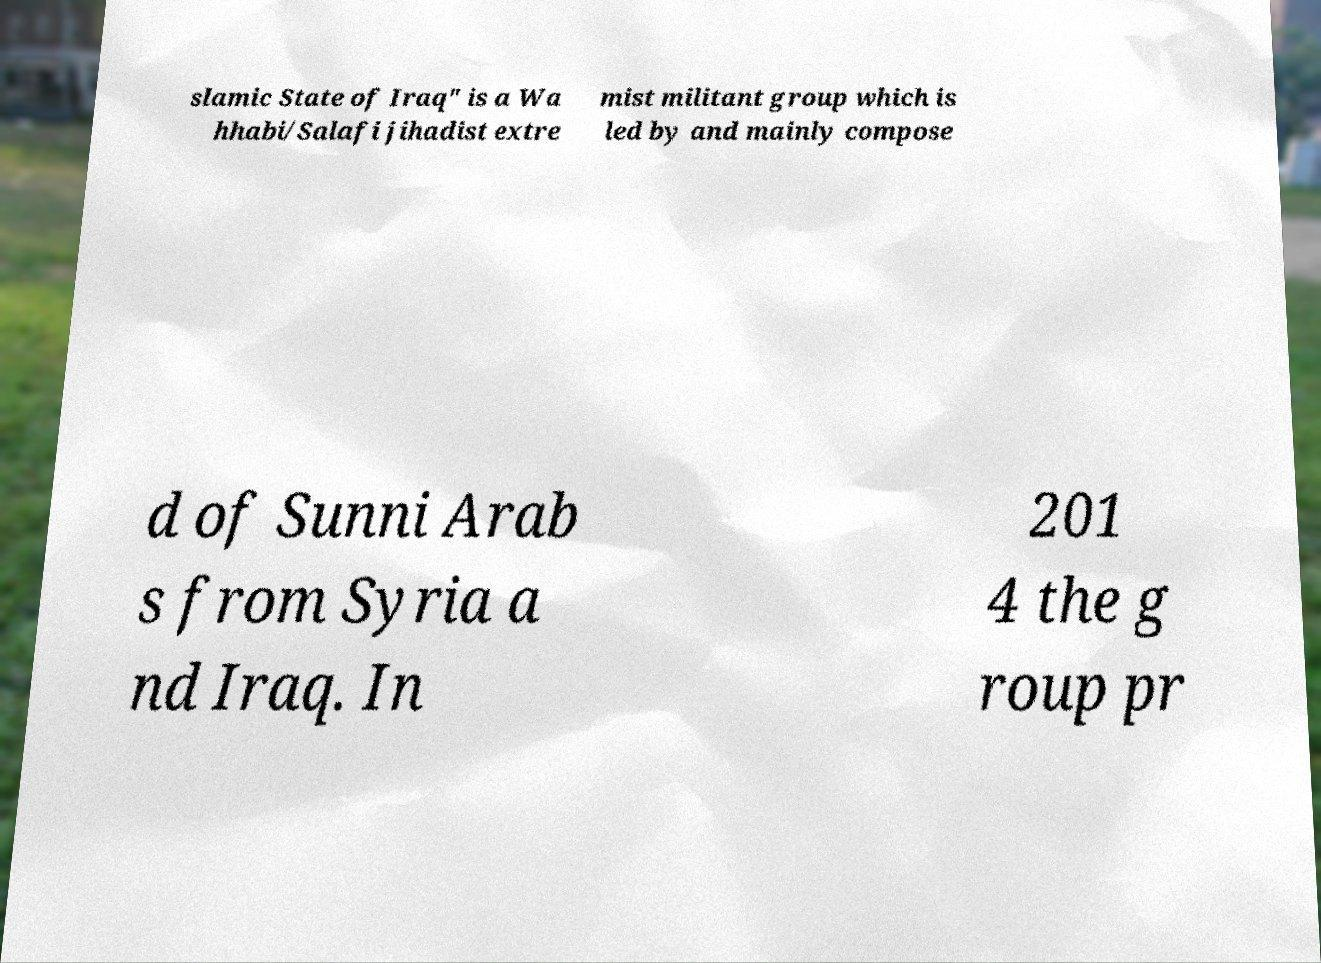There's text embedded in this image that I need extracted. Can you transcribe it verbatim? slamic State of Iraq" is a Wa hhabi/Salafi jihadist extre mist militant group which is led by and mainly compose d of Sunni Arab s from Syria a nd Iraq. In 201 4 the g roup pr 